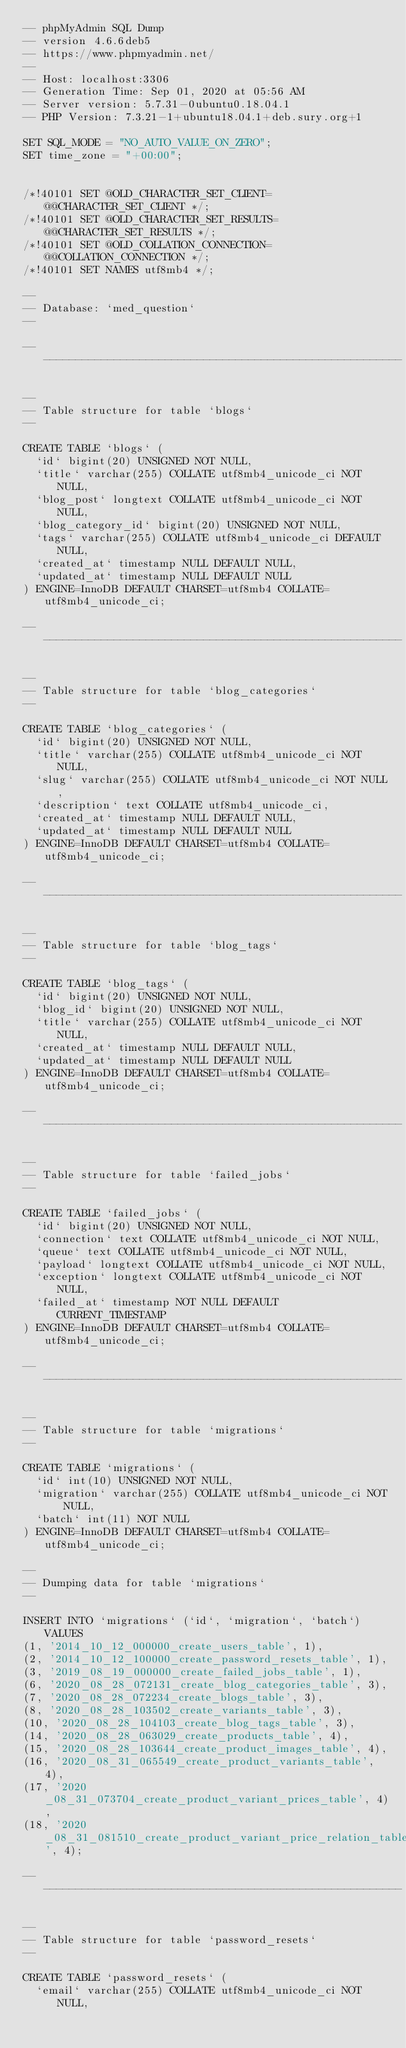Convert code to text. <code><loc_0><loc_0><loc_500><loc_500><_SQL_>-- phpMyAdmin SQL Dump
-- version 4.6.6deb5
-- https://www.phpmyadmin.net/
--
-- Host: localhost:3306
-- Generation Time: Sep 01, 2020 at 05:56 AM
-- Server version: 5.7.31-0ubuntu0.18.04.1
-- PHP Version: 7.3.21-1+ubuntu18.04.1+deb.sury.org+1

SET SQL_MODE = "NO_AUTO_VALUE_ON_ZERO";
SET time_zone = "+00:00";


/*!40101 SET @OLD_CHARACTER_SET_CLIENT=@@CHARACTER_SET_CLIENT */;
/*!40101 SET @OLD_CHARACTER_SET_RESULTS=@@CHARACTER_SET_RESULTS */;
/*!40101 SET @OLD_COLLATION_CONNECTION=@@COLLATION_CONNECTION */;
/*!40101 SET NAMES utf8mb4 */;

--
-- Database: `med_question`
--

-- --------------------------------------------------------

--
-- Table structure for table `blogs`
--

CREATE TABLE `blogs` (
  `id` bigint(20) UNSIGNED NOT NULL,
  `title` varchar(255) COLLATE utf8mb4_unicode_ci NOT NULL,
  `blog_post` longtext COLLATE utf8mb4_unicode_ci NOT NULL,
  `blog_category_id` bigint(20) UNSIGNED NOT NULL,
  `tags` varchar(255) COLLATE utf8mb4_unicode_ci DEFAULT NULL,
  `created_at` timestamp NULL DEFAULT NULL,
  `updated_at` timestamp NULL DEFAULT NULL
) ENGINE=InnoDB DEFAULT CHARSET=utf8mb4 COLLATE=utf8mb4_unicode_ci;

-- --------------------------------------------------------

--
-- Table structure for table `blog_categories`
--

CREATE TABLE `blog_categories` (
  `id` bigint(20) UNSIGNED NOT NULL,
  `title` varchar(255) COLLATE utf8mb4_unicode_ci NOT NULL,
  `slug` varchar(255) COLLATE utf8mb4_unicode_ci NOT NULL,
  `description` text COLLATE utf8mb4_unicode_ci,
  `created_at` timestamp NULL DEFAULT NULL,
  `updated_at` timestamp NULL DEFAULT NULL
) ENGINE=InnoDB DEFAULT CHARSET=utf8mb4 COLLATE=utf8mb4_unicode_ci;

-- --------------------------------------------------------

--
-- Table structure for table `blog_tags`
--

CREATE TABLE `blog_tags` (
  `id` bigint(20) UNSIGNED NOT NULL,
  `blog_id` bigint(20) UNSIGNED NOT NULL,
  `title` varchar(255) COLLATE utf8mb4_unicode_ci NOT NULL,
  `created_at` timestamp NULL DEFAULT NULL,
  `updated_at` timestamp NULL DEFAULT NULL
) ENGINE=InnoDB DEFAULT CHARSET=utf8mb4 COLLATE=utf8mb4_unicode_ci;

-- --------------------------------------------------------

--
-- Table structure for table `failed_jobs`
--

CREATE TABLE `failed_jobs` (
  `id` bigint(20) UNSIGNED NOT NULL,
  `connection` text COLLATE utf8mb4_unicode_ci NOT NULL,
  `queue` text COLLATE utf8mb4_unicode_ci NOT NULL,
  `payload` longtext COLLATE utf8mb4_unicode_ci NOT NULL,
  `exception` longtext COLLATE utf8mb4_unicode_ci NOT NULL,
  `failed_at` timestamp NOT NULL DEFAULT CURRENT_TIMESTAMP
) ENGINE=InnoDB DEFAULT CHARSET=utf8mb4 COLLATE=utf8mb4_unicode_ci;

-- --------------------------------------------------------

--
-- Table structure for table `migrations`
--

CREATE TABLE `migrations` (
  `id` int(10) UNSIGNED NOT NULL,
  `migration` varchar(255) COLLATE utf8mb4_unicode_ci NOT NULL,
  `batch` int(11) NOT NULL
) ENGINE=InnoDB DEFAULT CHARSET=utf8mb4 COLLATE=utf8mb4_unicode_ci;

--
-- Dumping data for table `migrations`
--

INSERT INTO `migrations` (`id`, `migration`, `batch`) VALUES
(1, '2014_10_12_000000_create_users_table', 1),
(2, '2014_10_12_100000_create_password_resets_table', 1),
(3, '2019_08_19_000000_create_failed_jobs_table', 1),
(6, '2020_08_28_072131_create_blog_categories_table', 3),
(7, '2020_08_28_072234_create_blogs_table', 3),
(8, '2020_08_28_103502_create_variants_table', 3),
(10, '2020_08_28_104103_create_blog_tags_table', 3),
(14, '2020_08_28_063029_create_products_table', 4),
(15, '2020_08_28_103644_create_product_images_table', 4),
(16, '2020_08_31_065549_create_product_variants_table', 4),
(17, '2020_08_31_073704_create_product_variant_prices_table', 4),
(18, '2020_08_31_081510_create_product_variant_price_relation_table', 4);

-- --------------------------------------------------------

--
-- Table structure for table `password_resets`
--

CREATE TABLE `password_resets` (
  `email` varchar(255) COLLATE utf8mb4_unicode_ci NOT NULL,</code> 